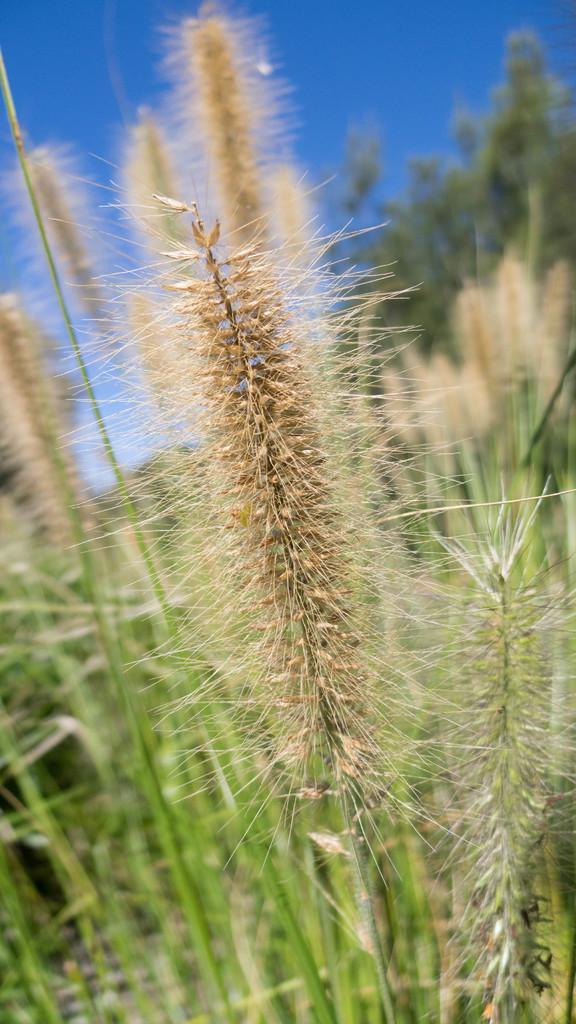How would you summarize this image in a sentence or two? In this picture I can observe plants. In the background I can observe a sky. 